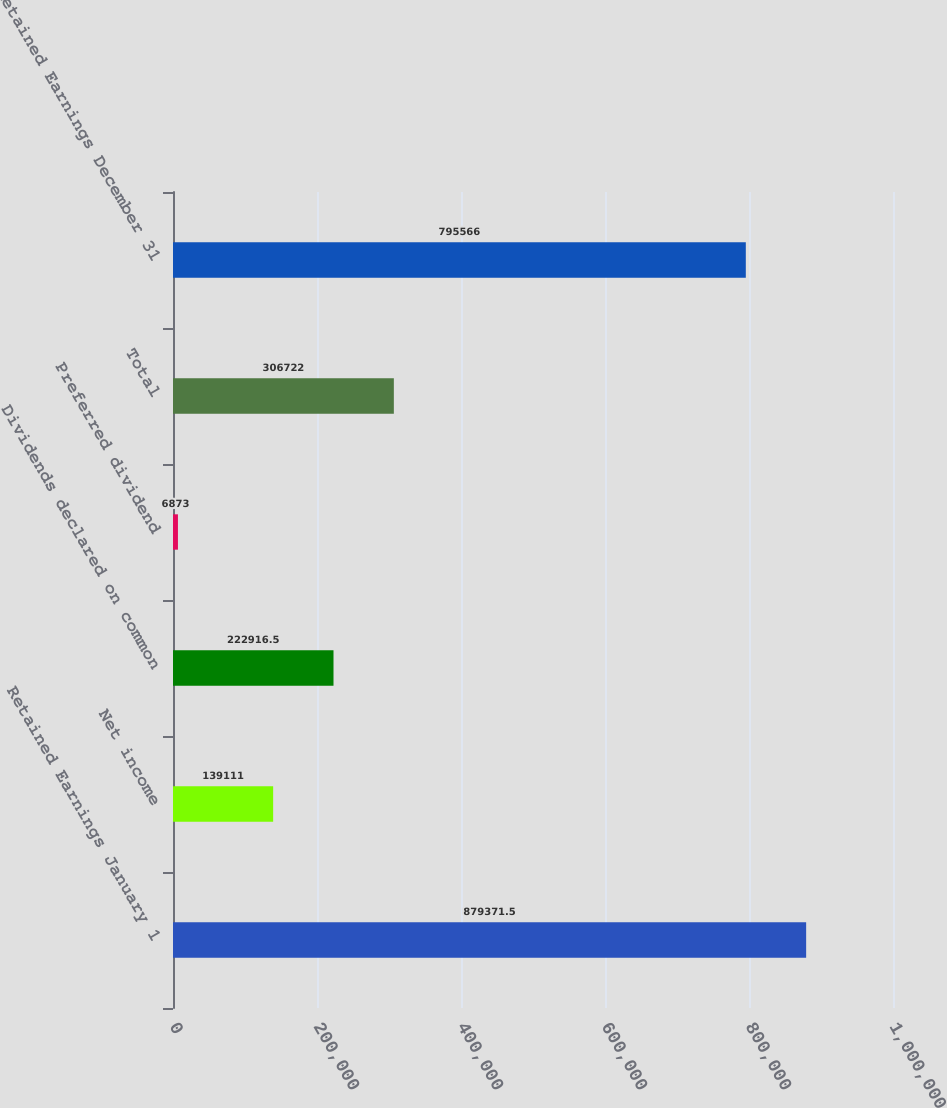<chart> <loc_0><loc_0><loc_500><loc_500><bar_chart><fcel>Retained Earnings January 1<fcel>Net income<fcel>Dividends declared on common<fcel>Preferred dividend<fcel>Total<fcel>Retained Earnings December 31<nl><fcel>879372<fcel>139111<fcel>222916<fcel>6873<fcel>306722<fcel>795566<nl></chart> 